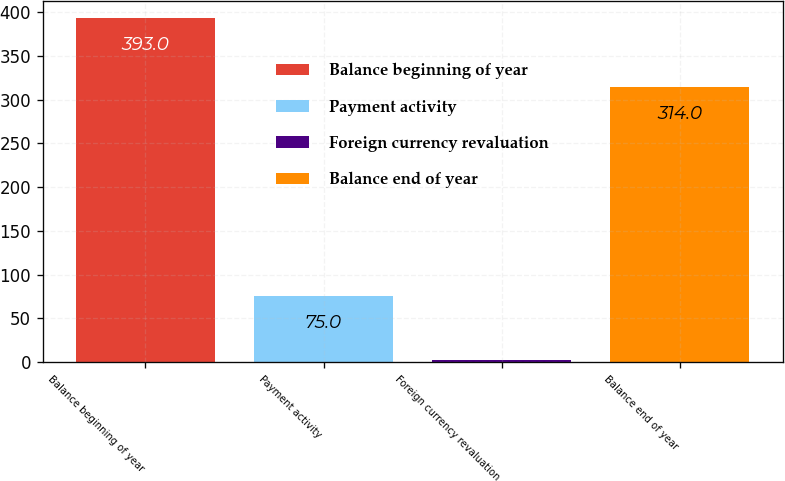<chart> <loc_0><loc_0><loc_500><loc_500><bar_chart><fcel>Balance beginning of year<fcel>Payment activity<fcel>Foreign currency revaluation<fcel>Balance end of year<nl><fcel>393<fcel>75<fcel>2<fcel>314<nl></chart> 